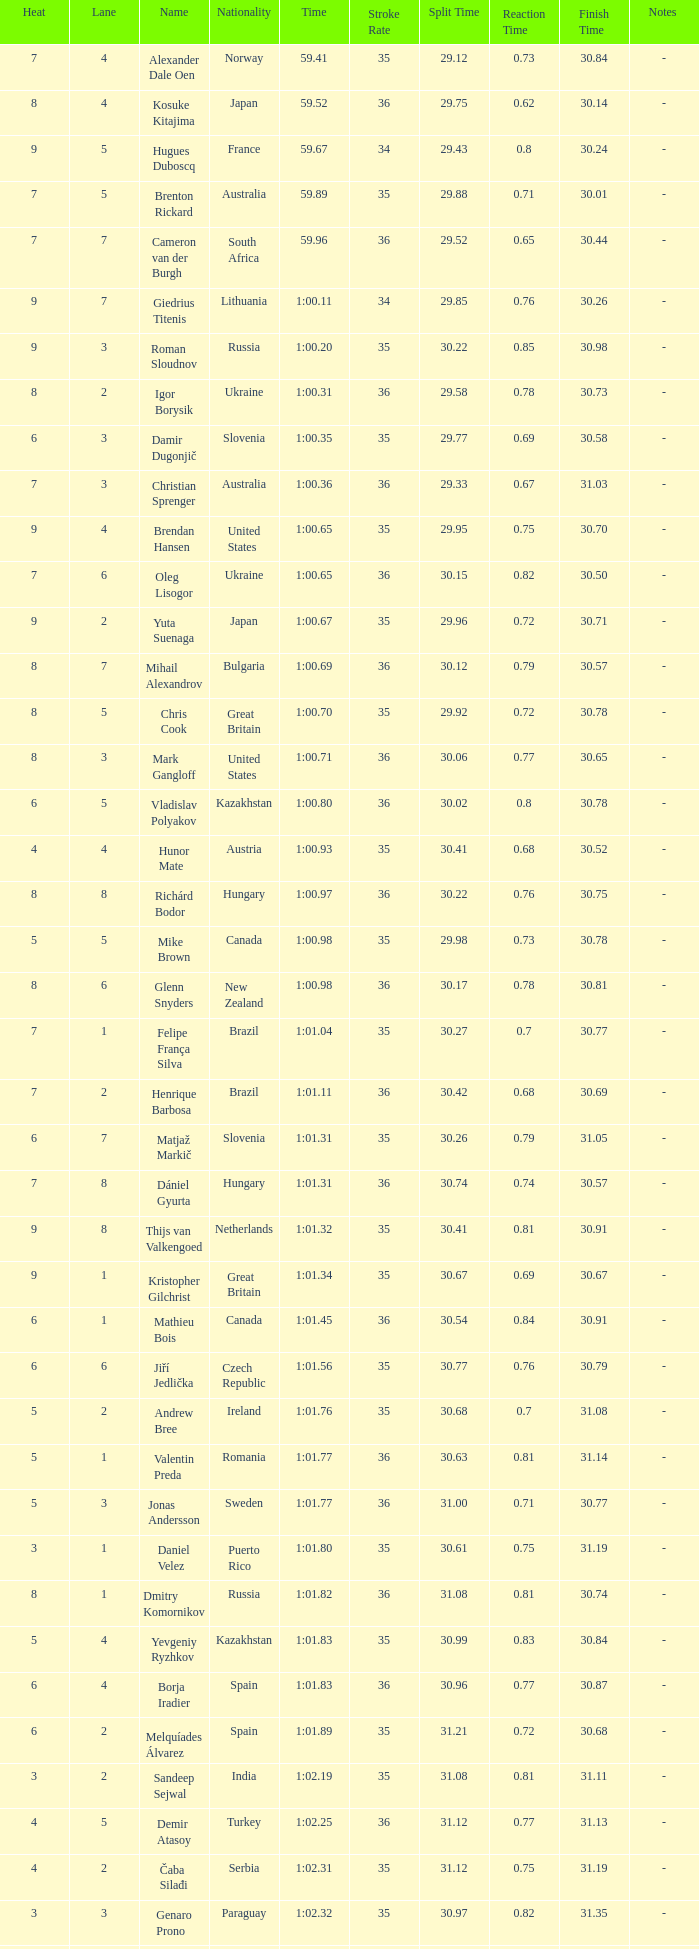What is the smallest lane number of Xue Ruipeng? 8.0. 